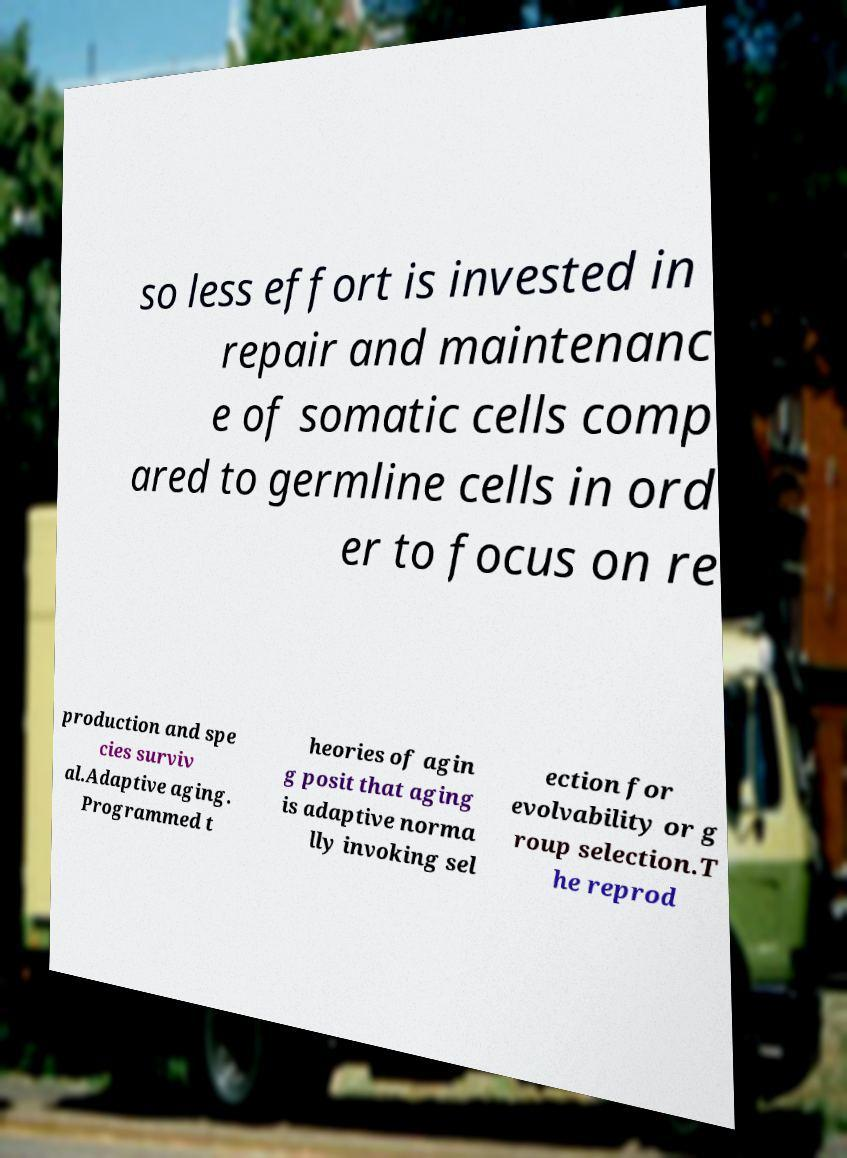Please read and relay the text visible in this image. What does it say? so less effort is invested in repair and maintenanc e of somatic cells comp ared to germline cells in ord er to focus on re production and spe cies surviv al.Adaptive aging. Programmed t heories of agin g posit that aging is adaptive norma lly invoking sel ection for evolvability or g roup selection.T he reprod 